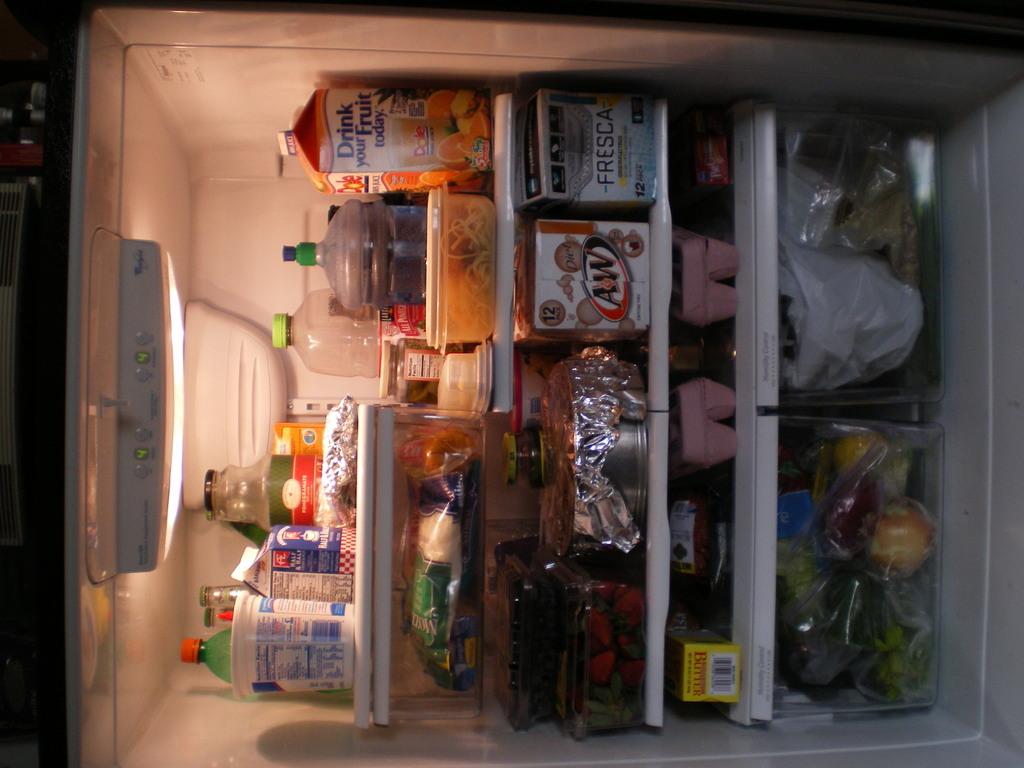What soda is in this fridge?
Provide a succinct answer. A&w. What juice is in the fridge?
Give a very brief answer. Orange. 